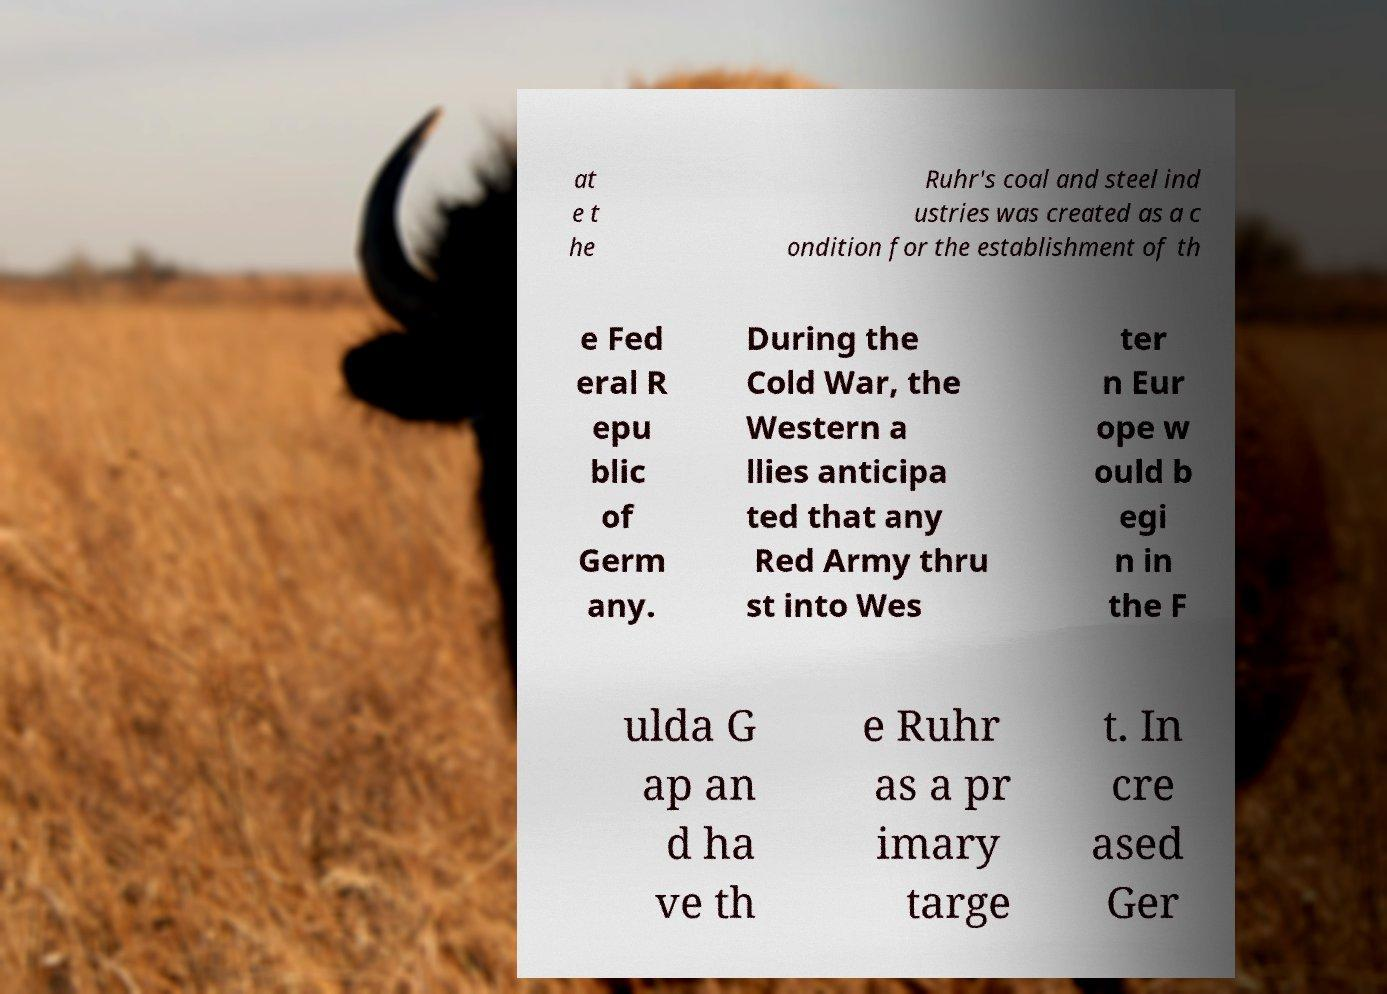Please read and relay the text visible in this image. What does it say? at e t he Ruhr's coal and steel ind ustries was created as a c ondition for the establishment of th e Fed eral R epu blic of Germ any. During the Cold War, the Western a llies anticipa ted that any Red Army thru st into Wes ter n Eur ope w ould b egi n in the F ulda G ap an d ha ve th e Ruhr as a pr imary targe t. In cre ased Ger 